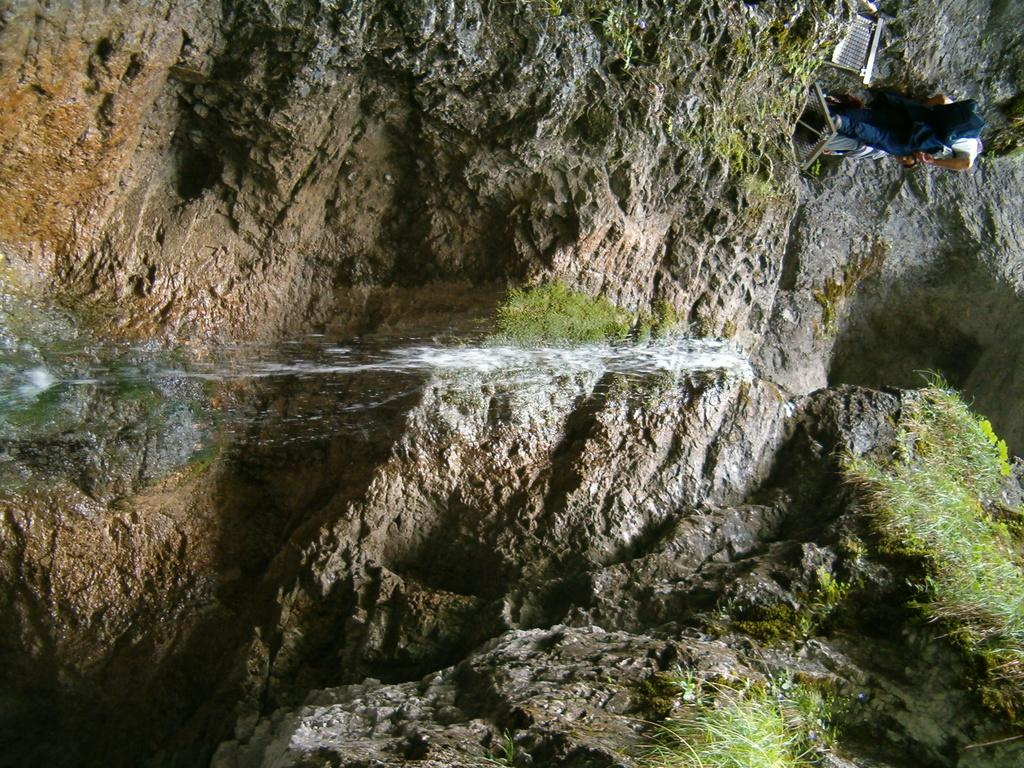What is the person in the image doing? The person is standing on a rock in the image. What is located beside the person? There is a metal bench beside the person. What is happening with the water in the image? Water is falling from the top in the image. What type of vegetation can be seen on the rocks? There is grass on the rocks in the image. What type of lettuce is being used to support the person standing on the rock in the image? There is no lettuce present in the image, and it is not being used to support the person standing on the rock. 